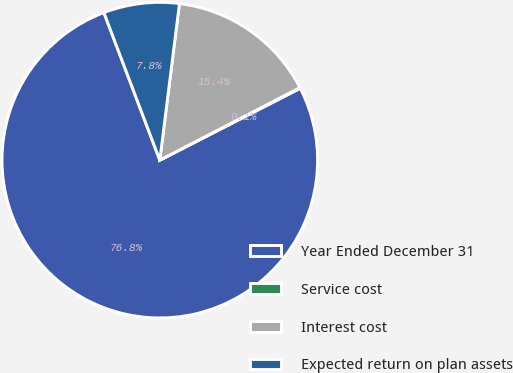Convert chart. <chart><loc_0><loc_0><loc_500><loc_500><pie_chart><fcel>Year Ended December 31<fcel>Service cost<fcel>Interest cost<fcel>Expected return on plan assets<nl><fcel>76.76%<fcel>0.08%<fcel>15.41%<fcel>7.75%<nl></chart> 